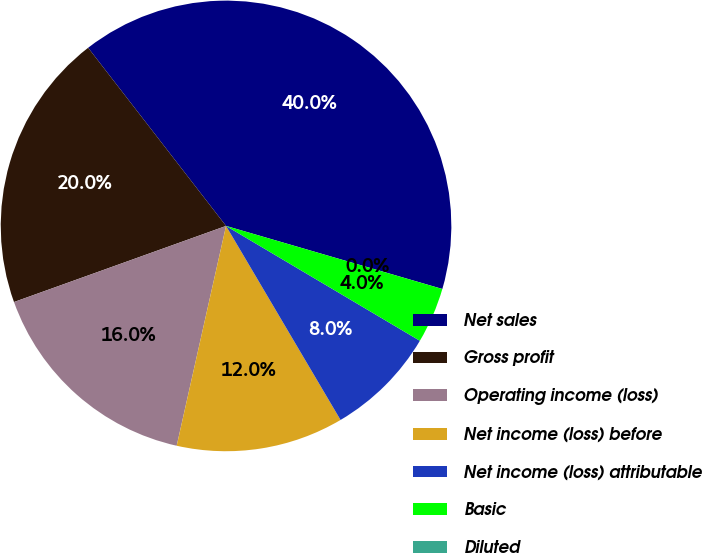Convert chart. <chart><loc_0><loc_0><loc_500><loc_500><pie_chart><fcel>Net sales<fcel>Gross profit<fcel>Operating income (loss)<fcel>Net income (loss) before<fcel>Net income (loss) attributable<fcel>Basic<fcel>Diluted<nl><fcel>40.0%<fcel>20.0%<fcel>16.0%<fcel>12.0%<fcel>8.0%<fcel>4.0%<fcel>0.0%<nl></chart> 